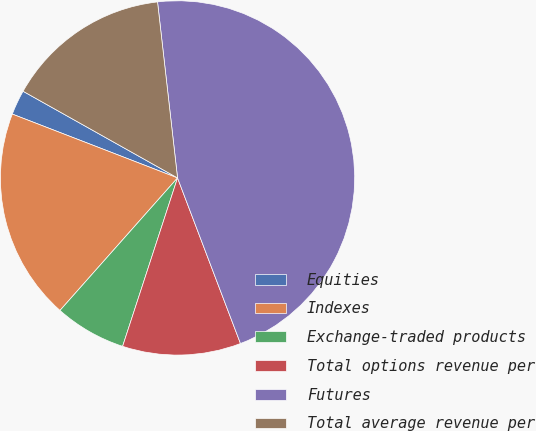Convert chart to OTSL. <chart><loc_0><loc_0><loc_500><loc_500><pie_chart><fcel>Equities<fcel>Indexes<fcel>Exchange-traded products<fcel>Total options revenue per<fcel>Futures<fcel>Total average revenue per<nl><fcel>2.27%<fcel>19.32%<fcel>6.53%<fcel>10.8%<fcel>46.02%<fcel>15.06%<nl></chart> 